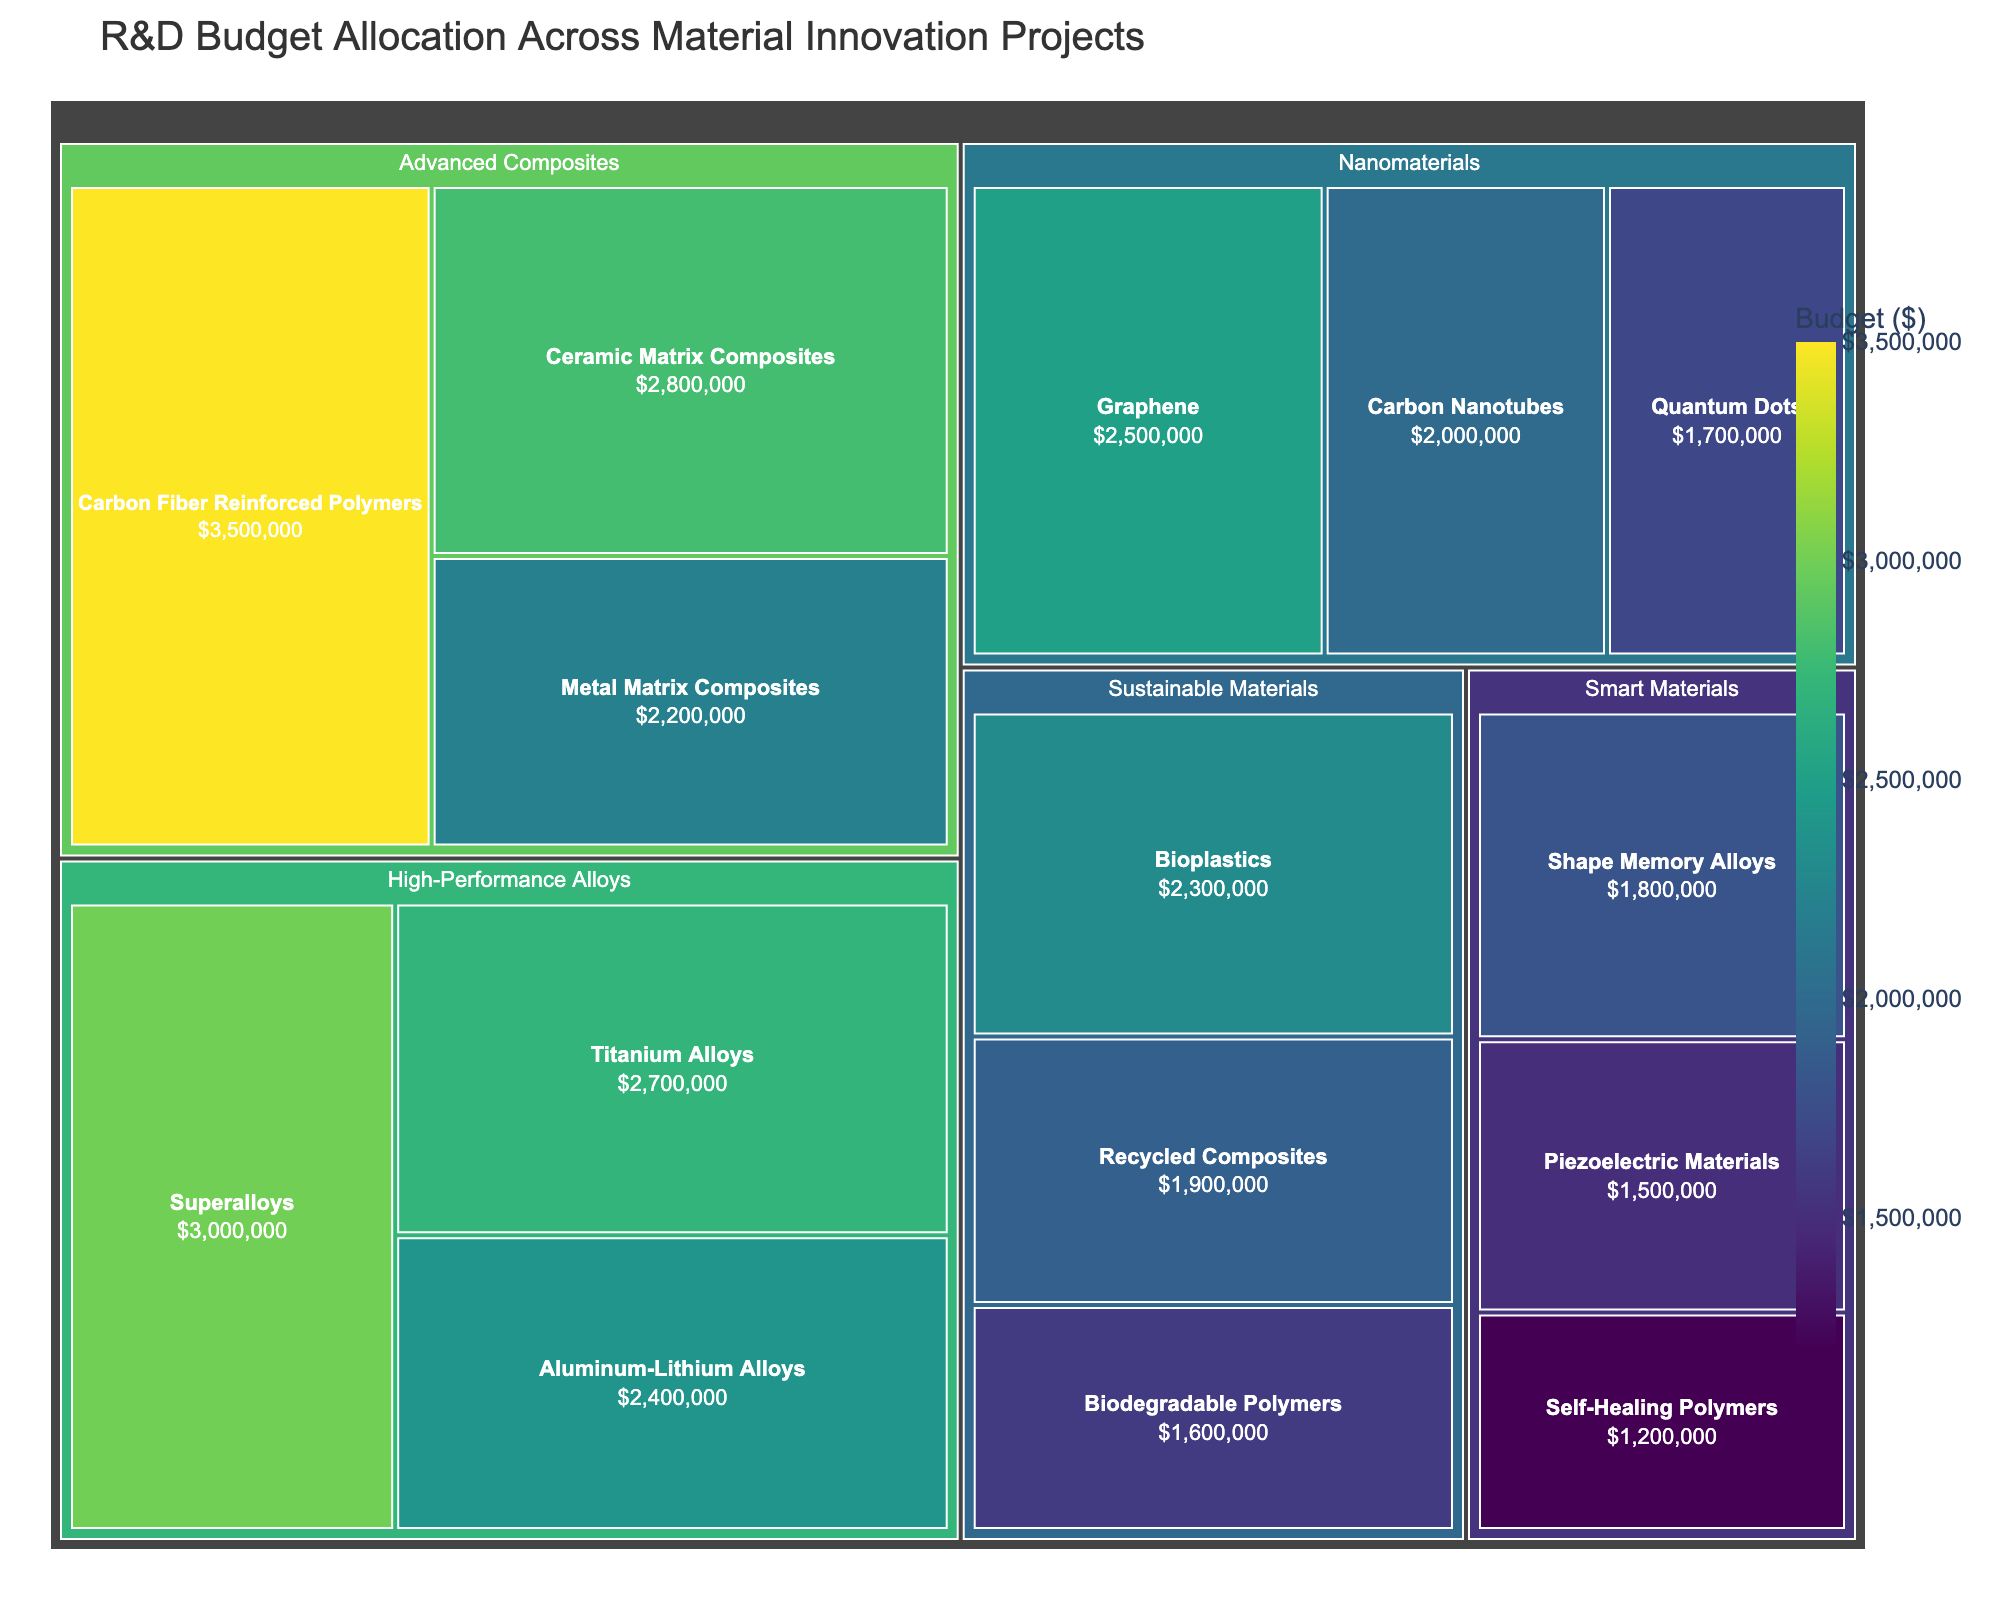What's the largest budget allocation among the subcategories? Look for the subcategory with the largest rectangle in the treemap. "Carbon Fiber Reinforced Polymers" under "Advanced Composites" has the largest budget allocation at $3,500,000.
Answer: Carbon Fiber Reinforced Polymers Which category has the smallest total budget allocation? Sum the budgets of each subcategory within all categories and compare. "Smart Materials" has a total budget of $4,500,000 (1,800,000 + 1,500,000 + 1,200,000), which is the smallest.
Answer: Smart Materials What is the total budget allocated to "Advanced Composites"? Add the budget values of all subcategories under "Advanced Composites": 3,500,000 + 2,800,000 + 2,200,000.
Answer: $8,500,000 How does the budget for "Bioplastics" compare to "Graphene"? Look at the budget values directly. "Bioplastics" has a budget of $2,300,000 and "Graphene" has $2,500,000, so Graphene has a higher budget.
Answer: Graphene has a higher budget What's the average budget of the subcategories under "High-Performance Alloys"? Sum the budgets of the subcategories and divide by the number of subcategories: (3,000,000 + 2,700,000 + 2,400,000)/3.
Answer: $2,700,000 Which subcategory in "Sustainable Materials" has the highest budget allocation? Compare the budgets of subcategories under "Sustainable Materials". "Bioplastics" has the highest budget.
Answer: Bioplastics Are there more subcategories under "Nanomaterials" or "Smart Materials"? Count the subcategories under each category. "Nanomaterials" has 3 subcategories and "Smart Materials" also has 3.
Answer: Equal number What is the combined budget for all subcategories under “Nanomaterials” and “Sustainable Materials”? Add the total budget for each category. "Nanomaterials": 2,500,000 + 2,000,000 + 1,700,000 and "Sustainable Materials": 2,300,000 + 1,900,000 + 1,600,000.
Answer: $12,000,000 Which subcategory among all has the lowest budget allocation? Identify the subcategory visually with the smallest rectangle. "Self-Healing Polymers" has the lowest budget at $1,200,000.
Answer: Self-Healing Polymers 